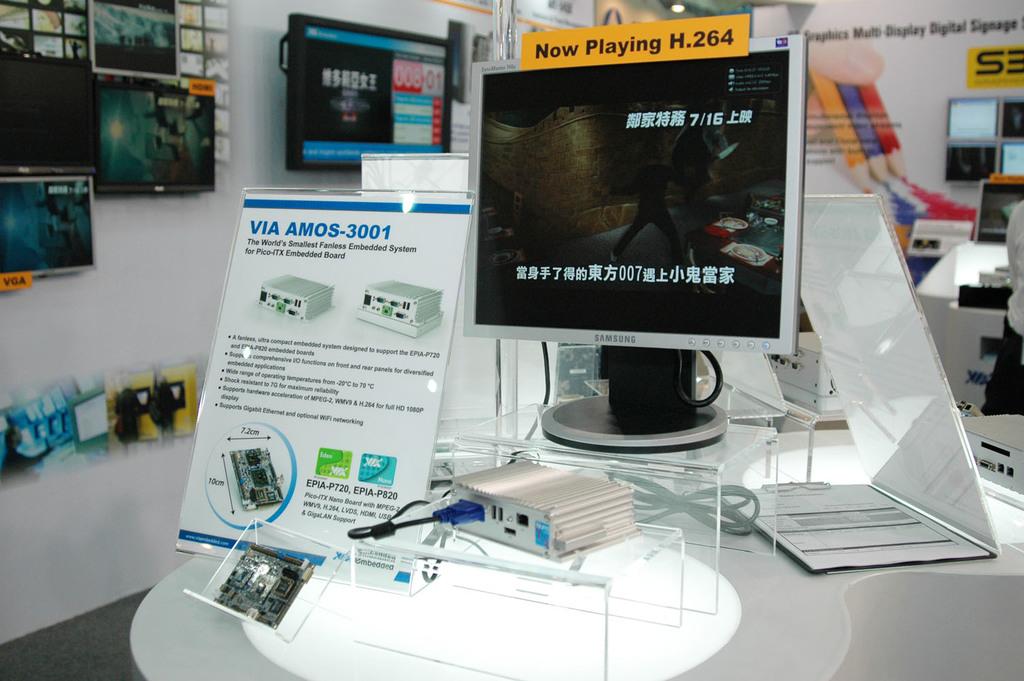What is the number on the top of the computer?
Ensure brevity in your answer.  264. 